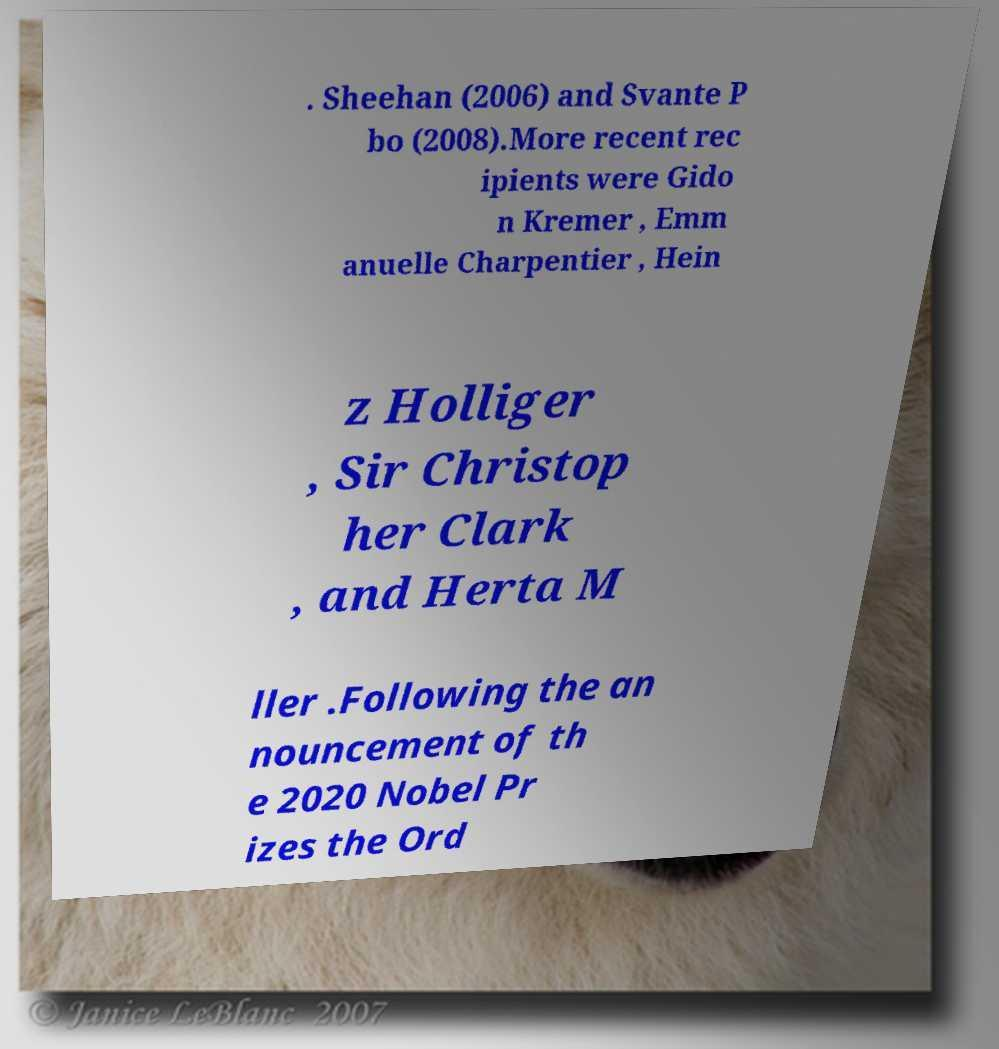There's text embedded in this image that I need extracted. Can you transcribe it verbatim? . Sheehan (2006) and Svante P bo (2008).More recent rec ipients were Gido n Kremer , Emm anuelle Charpentier , Hein z Holliger , Sir Christop her Clark , and Herta M ller .Following the an nouncement of th e 2020 Nobel Pr izes the Ord 